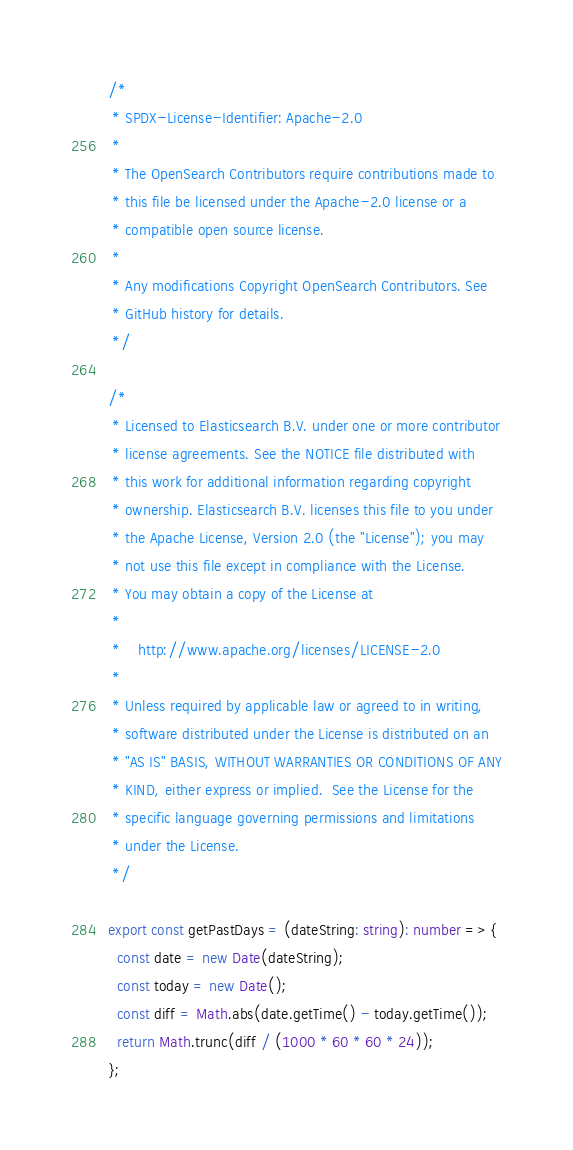<code> <loc_0><loc_0><loc_500><loc_500><_TypeScript_>/*
 * SPDX-License-Identifier: Apache-2.0
 *
 * The OpenSearch Contributors require contributions made to
 * this file be licensed under the Apache-2.0 license or a
 * compatible open source license.
 *
 * Any modifications Copyright OpenSearch Contributors. See
 * GitHub history for details.
 */

/*
 * Licensed to Elasticsearch B.V. under one or more contributor
 * license agreements. See the NOTICE file distributed with
 * this work for additional information regarding copyright
 * ownership. Elasticsearch B.V. licenses this file to you under
 * the Apache License, Version 2.0 (the "License"); you may
 * not use this file except in compliance with the License.
 * You may obtain a copy of the License at
 *
 *    http://www.apache.org/licenses/LICENSE-2.0
 *
 * Unless required by applicable law or agreed to in writing,
 * software distributed under the License is distributed on an
 * "AS IS" BASIS, WITHOUT WARRANTIES OR CONDITIONS OF ANY
 * KIND, either express or implied.  See the License for the
 * specific language governing permissions and limitations
 * under the License.
 */

export const getPastDays = (dateString: string): number => {
  const date = new Date(dateString);
  const today = new Date();
  const diff = Math.abs(date.getTime() - today.getTime());
  return Math.trunc(diff / (1000 * 60 * 60 * 24));
};
</code> 